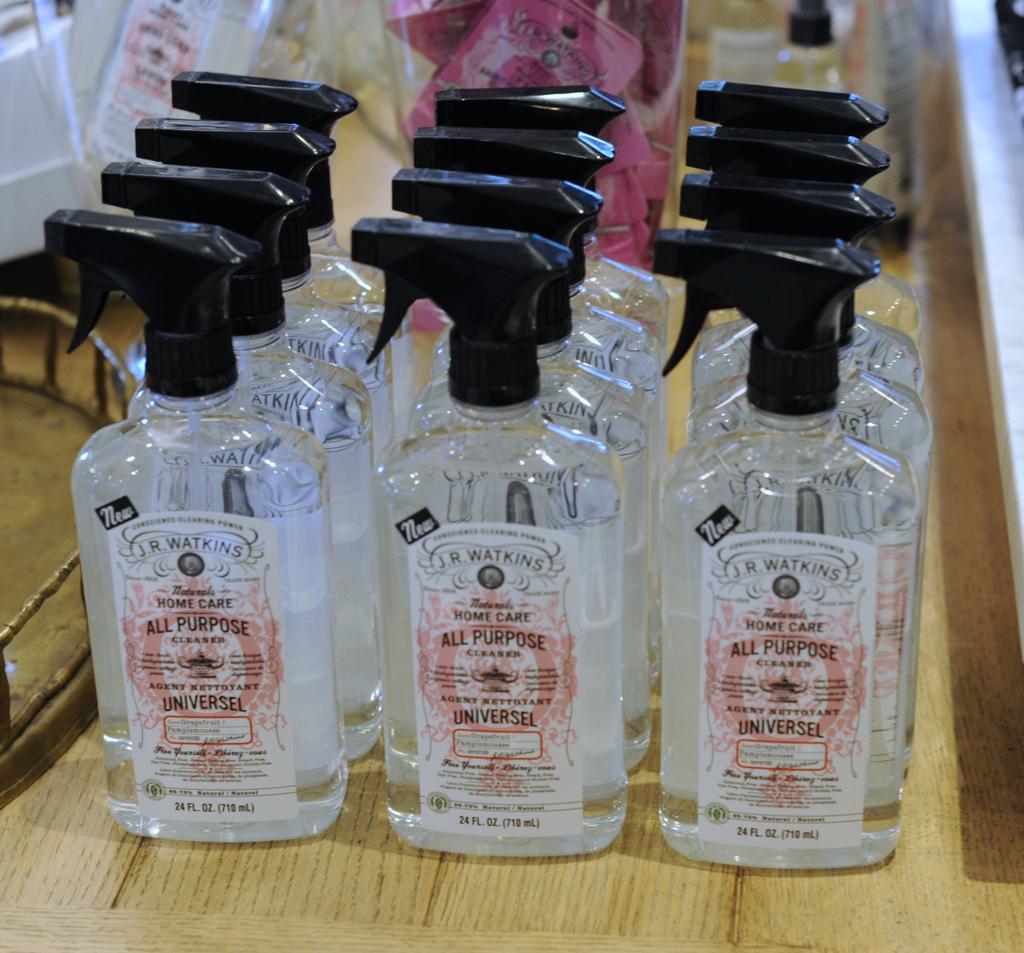How many fluid ounces in each bottle?
Ensure brevity in your answer.  24. What is the brand name of these?
Your response must be concise. J.r. watkins. 